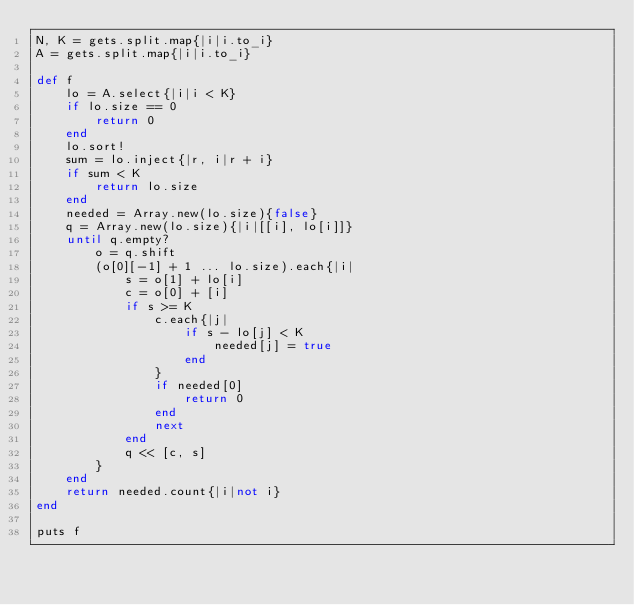Convert code to text. <code><loc_0><loc_0><loc_500><loc_500><_Ruby_>N, K = gets.split.map{|i|i.to_i}
A = gets.split.map{|i|i.to_i}

def f
	lo = A.select{|i|i < K}
	if lo.size == 0
		return 0
	end
	lo.sort!
	sum = lo.inject{|r, i|r + i}
	if sum < K
		return lo.size
	end
	needed = Array.new(lo.size){false}
	q = Array.new(lo.size){|i|[[i], lo[i]]}
	until q.empty?
		o = q.shift
		(o[0][-1] + 1 ... lo.size).each{|i|
			s = o[1] + lo[i]
			c = o[0] + [i]
			if s >= K
				c.each{|j|
					if s - lo[j] < K
						needed[j] = true
					end
				}
				if needed[0]
					return 0
				end
				next
			end
			q << [c, s]
		}
	end
	return needed.count{|i|not i}
end

puts f
</code> 